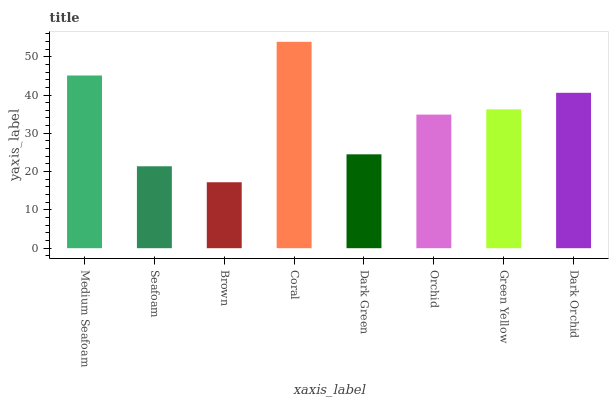Is Brown the minimum?
Answer yes or no. Yes. Is Coral the maximum?
Answer yes or no. Yes. Is Seafoam the minimum?
Answer yes or no. No. Is Seafoam the maximum?
Answer yes or no. No. Is Medium Seafoam greater than Seafoam?
Answer yes or no. Yes. Is Seafoam less than Medium Seafoam?
Answer yes or no. Yes. Is Seafoam greater than Medium Seafoam?
Answer yes or no. No. Is Medium Seafoam less than Seafoam?
Answer yes or no. No. Is Green Yellow the high median?
Answer yes or no. Yes. Is Orchid the low median?
Answer yes or no. Yes. Is Coral the high median?
Answer yes or no. No. Is Medium Seafoam the low median?
Answer yes or no. No. 